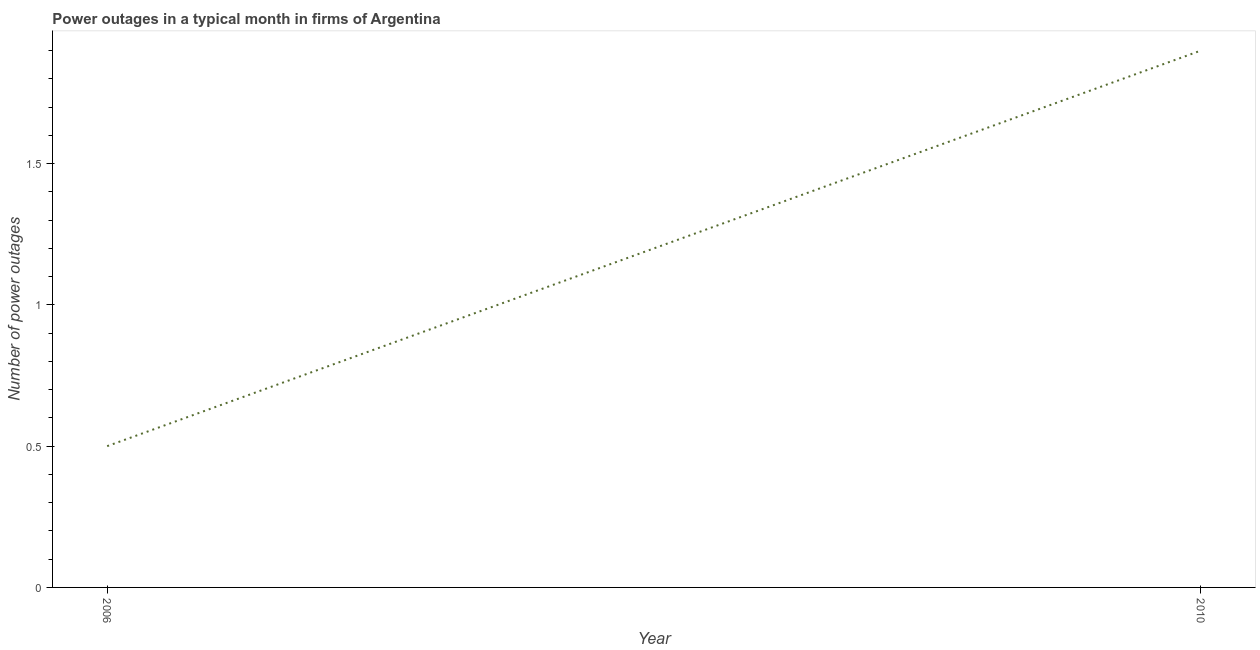What is the number of power outages in 2010?
Provide a succinct answer. 1.9. Across all years, what is the maximum number of power outages?
Your answer should be very brief. 1.9. Across all years, what is the minimum number of power outages?
Offer a very short reply. 0.5. In which year was the number of power outages maximum?
Offer a very short reply. 2010. In which year was the number of power outages minimum?
Provide a succinct answer. 2006. In how many years, is the number of power outages greater than 1.6 ?
Your answer should be very brief. 1. What is the ratio of the number of power outages in 2006 to that in 2010?
Make the answer very short. 0.26. In how many years, is the number of power outages greater than the average number of power outages taken over all years?
Your response must be concise. 1. Does the number of power outages monotonically increase over the years?
Keep it short and to the point. Yes. How many lines are there?
Provide a succinct answer. 1. What is the difference between two consecutive major ticks on the Y-axis?
Your response must be concise. 0.5. Does the graph contain any zero values?
Ensure brevity in your answer.  No. What is the title of the graph?
Your answer should be very brief. Power outages in a typical month in firms of Argentina. What is the label or title of the Y-axis?
Keep it short and to the point. Number of power outages. What is the Number of power outages of 2006?
Make the answer very short. 0.5. What is the Number of power outages in 2010?
Give a very brief answer. 1.9. What is the ratio of the Number of power outages in 2006 to that in 2010?
Offer a terse response. 0.26. 